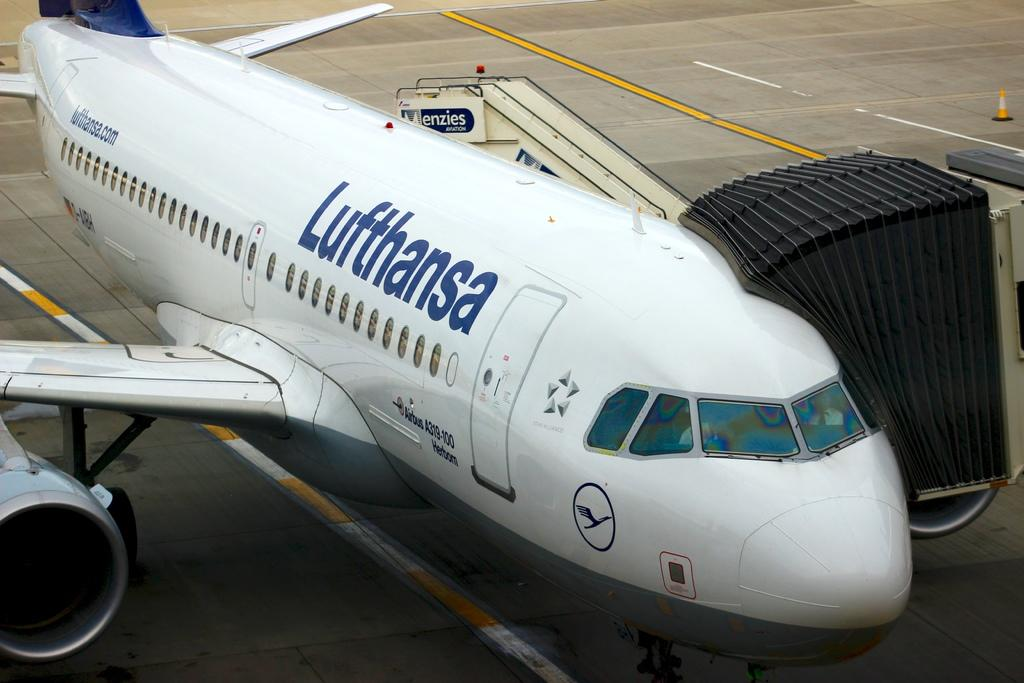What is the main subject of the image? The main subject of the image is an airplane. What type of surface is the airplane resting on? The airplane is on a concrete surface. Are there any other objects visible in the image? Yes, there is a traffic cone cup on the right side of the image. How many giants are visible in the image? There are no giants present in the image. Is the concrete surface covered in sleet in the image? The provided facts do not mention any weather conditions, so we cannot determine if the concrete surface is covered in sleet. 